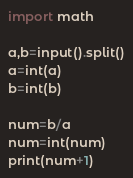<code> <loc_0><loc_0><loc_500><loc_500><_Python_>import math

a,b=input().split()
a=int(a)
b=int(b)

num=b/a
num=int(num)
print(num+1)</code> 